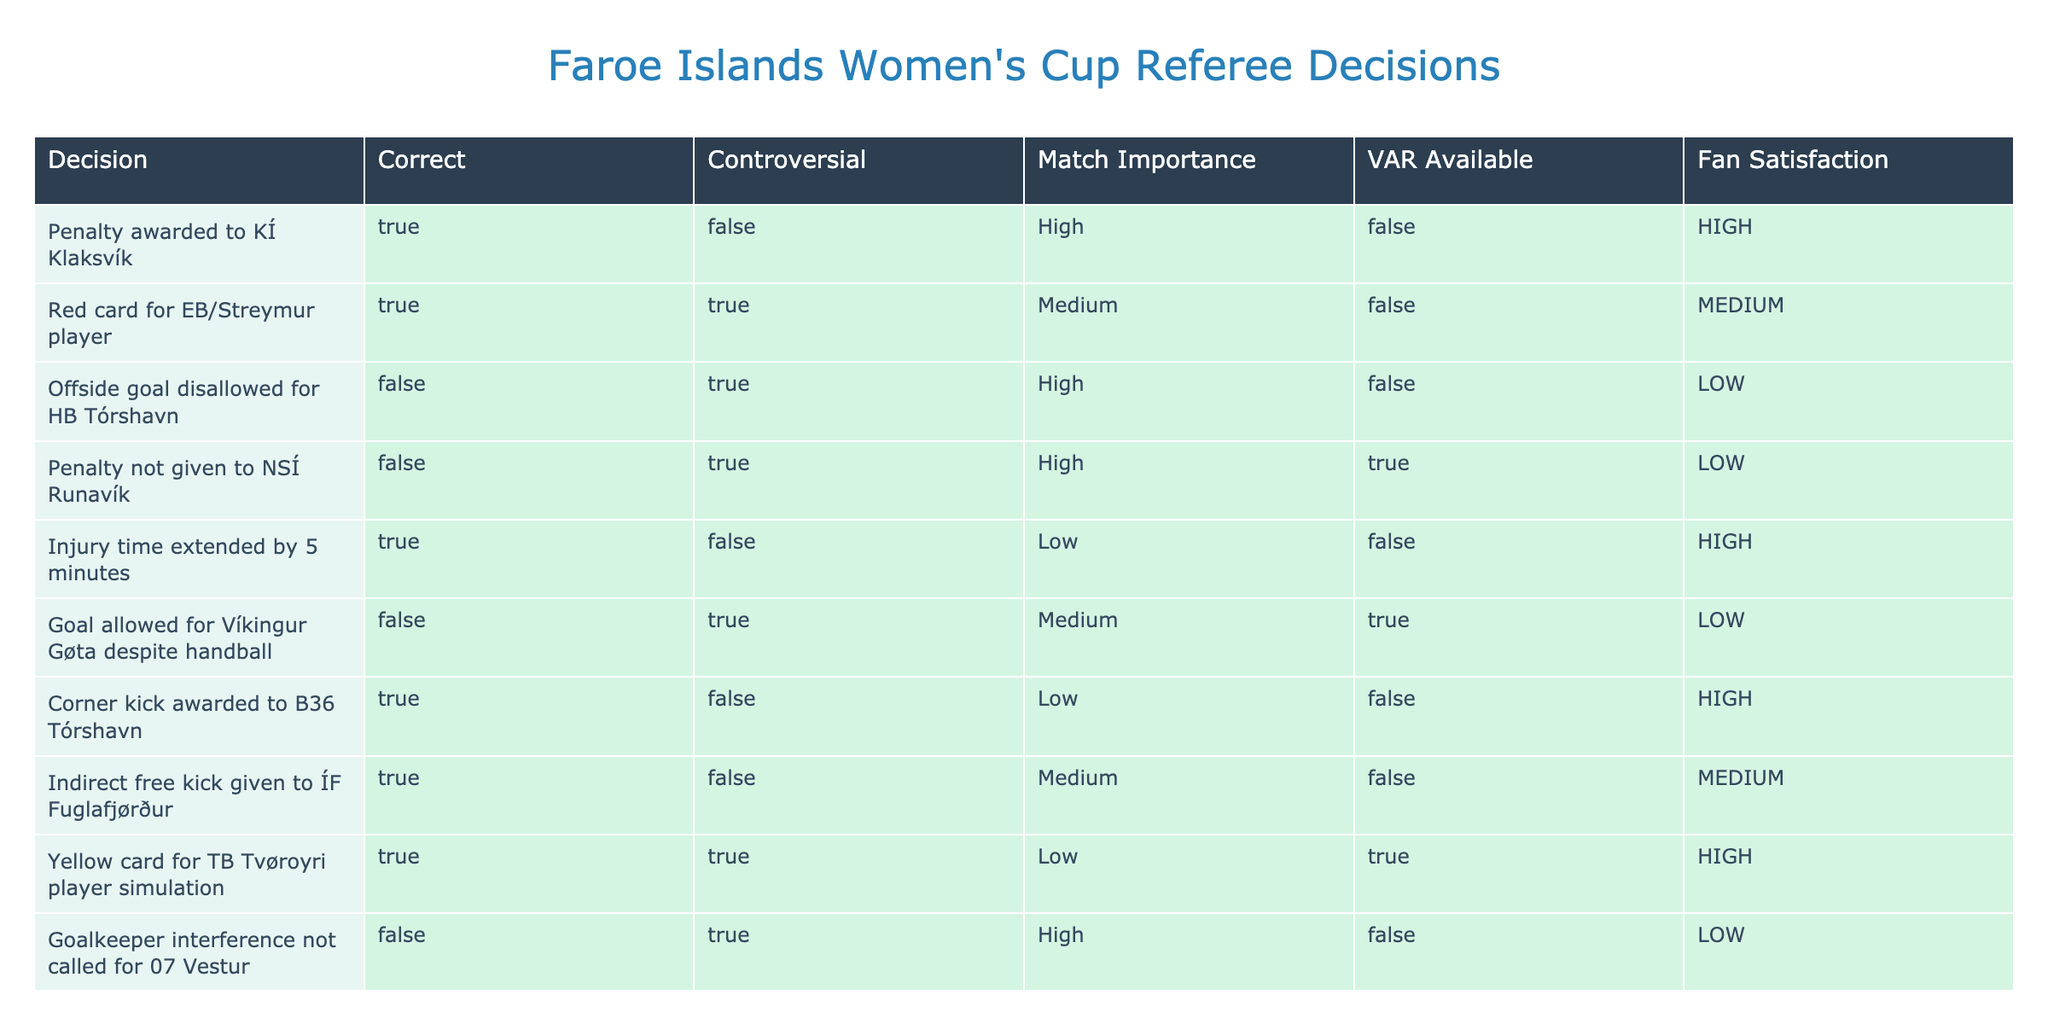What percentage of referee decisions were marked as correct? There are a total of 10 decisions in the table. Out of these, 6 decisions are marked as correct (KÍ Klaksvík penalty, EB/Streymur red card, injury time extension, corner kick for B36 Tórshavn, indirect free kick for ÍF Fuglafjørður, yellow card for TB Tvøroyri). To find the percentage of correct decisions, we calculate (6 correct / 10 total) * 100 = 60%.
Answer: 60% How many decisions resulted in high fan satisfaction? In the table, we identify decisions that have "HIGH" listed under the fan satisfaction column. The relevant decisions are the penalty awarded to KÍ Klaksvík, injury time extended by 5 minutes, and corner kick awarded to B36 Tórshavn, totaling 3 decisions with high fan satisfaction.
Answer: 3 Is it true that all controversial decisions were incorrect? To find out if this statement is true, we check the controversial column for rows where it is marked as true. There are 4 controversial decisions (red card for EB/Streymur, offside goal disallowed for HB Tórshavn, penalty not given to NSÍ Runavík, goal allowed for Víkingur Gøta despite handball), of which 2 are incorrect (offside goal and penalty not given). Hence, not all controversial decisions are incorrect; therefore, the answer is false.
Answer: False What is the average importance rating of the decisions made? There are 10 decisions with the following importance ratings: High (5), Medium (4), and Low (3). For calculation, we assign numerical values: High = 3, Medium = 2, Low = 1. There are 5 high, 3 medium, and 2 low ratings, so we calculate the total importance = (5*3) + (3*2) + (2*1) = 15 + 6 + 2 = 23. To find the average, we divide 23 by 10 (the total number of decisions) to get an average importance of 2.3.
Answer: 2.3 Which team experienced a correct and controversial decision simultaneously? In the table, we look for rows with "TRUE" under the Correct column and "TRUE" under the Controversial column. The only team that fits this description is EB/Streymur with the red card decision, which is marked as both correct and controversial.
Answer: EB/Streymur 